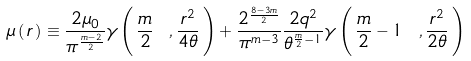<formula> <loc_0><loc_0><loc_500><loc_500>\mu \left ( \, r \, \right ) \equiv \frac { 2 \mu _ { 0 } } { \pi ^ { \frac { m - 2 } { 2 } } } \gamma \left ( \, \frac { m } { 2 } \ , \frac { r ^ { 2 } } { 4 \theta } \, \right ) + \frac { 2 ^ { \frac { 8 - 3 m } { 2 } } } { \pi ^ { m - 3 } } \frac { 2 q ^ { 2 } } { \theta ^ { \frac { m } { 2 } - 1 } } \gamma \left ( \, \frac { m } { 2 } - 1 \ , \frac { r ^ { 2 } } { 2 \theta } \, \right )</formula> 